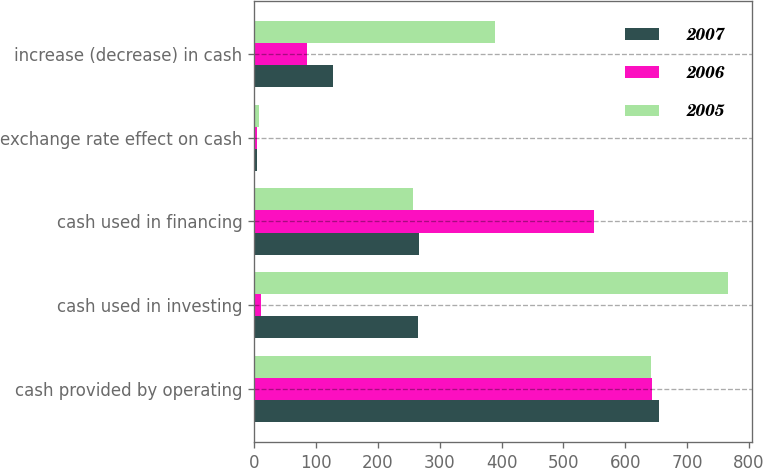Convert chart. <chart><loc_0><loc_0><loc_500><loc_500><stacked_bar_chart><ecel><fcel>cash provided by operating<fcel>cash used in investing<fcel>cash used in financing<fcel>exchange rate effect on cash<fcel>increase (decrease) in cash<nl><fcel>2007<fcel>655.3<fcel>265.6<fcel>266.8<fcel>5.3<fcel>128.2<nl><fcel>2006<fcel>643.4<fcel>11.9<fcel>550.1<fcel>4.1<fcel>85.5<nl><fcel>2005<fcel>641.6<fcel>766.7<fcel>257.2<fcel>7.8<fcel>390.1<nl></chart> 